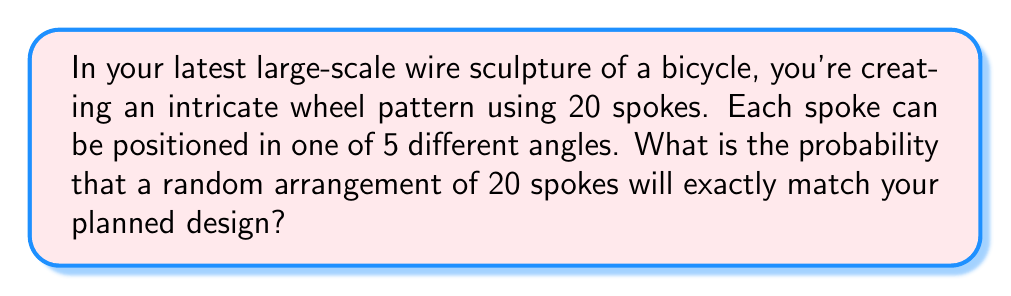Give your solution to this math problem. Let's approach this step-by-step:

1) First, we need to understand what we're calculating. We're looking for the probability of a specific arrangement out of all possible arrangements.

2) For each spoke, there are 5 possible positions. This is a case of independent events, as the position of one spoke doesn't affect the others.

3) We have 20 spokes in total. For each spoke, we need to choose the correct position out of 5 options.

4) This scenario follows the multiplication principle of probability. The probability of all events occurring is the product of their individual probabilities.

5) For a single spoke to be in the correct position, the probability is $\frac{1}{5}$.

6) We need this to happen for all 20 spokes. So we multiply this probability 20 times:

   $$P(\text{correct arrangement}) = (\frac{1}{5})^{20}$$

7) Let's calculate this:
   
   $$(\frac{1}{5})^{20} = \frac{1}{5^{20}} = \frac{1}{95,367,431,640,625}$$

8) We can also express this as a decimal:

   $$\frac{1}{95,367,431,640,625} \approx 1.048 \times 10^{-14}$$

This extremely small probability illustrates how unlikely it is for a random arrangement to match your specific design exactly.
Answer: $\frac{1}{95,367,431,640,625}$ or approximately $1.048 \times 10^{-14}$ 